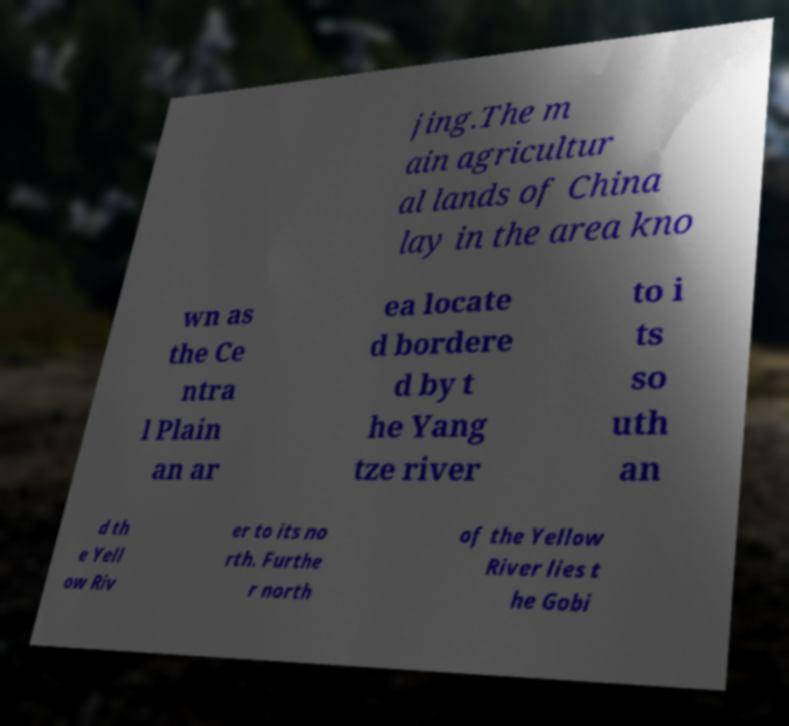I need the written content from this picture converted into text. Can you do that? jing.The m ain agricultur al lands of China lay in the area kno wn as the Ce ntra l Plain an ar ea locate d bordere d by t he Yang tze river to i ts so uth an d th e Yell ow Riv er to its no rth. Furthe r north of the Yellow River lies t he Gobi 